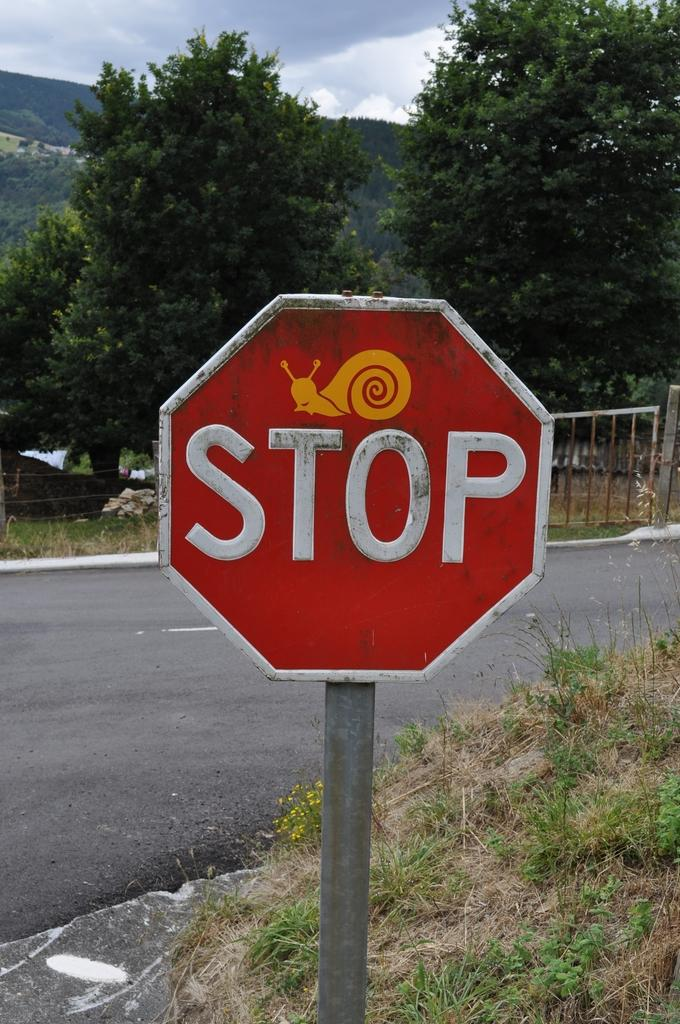<image>
Render a clear and concise summary of the photo. Large Stop sign with a sticker of a snail on it. 